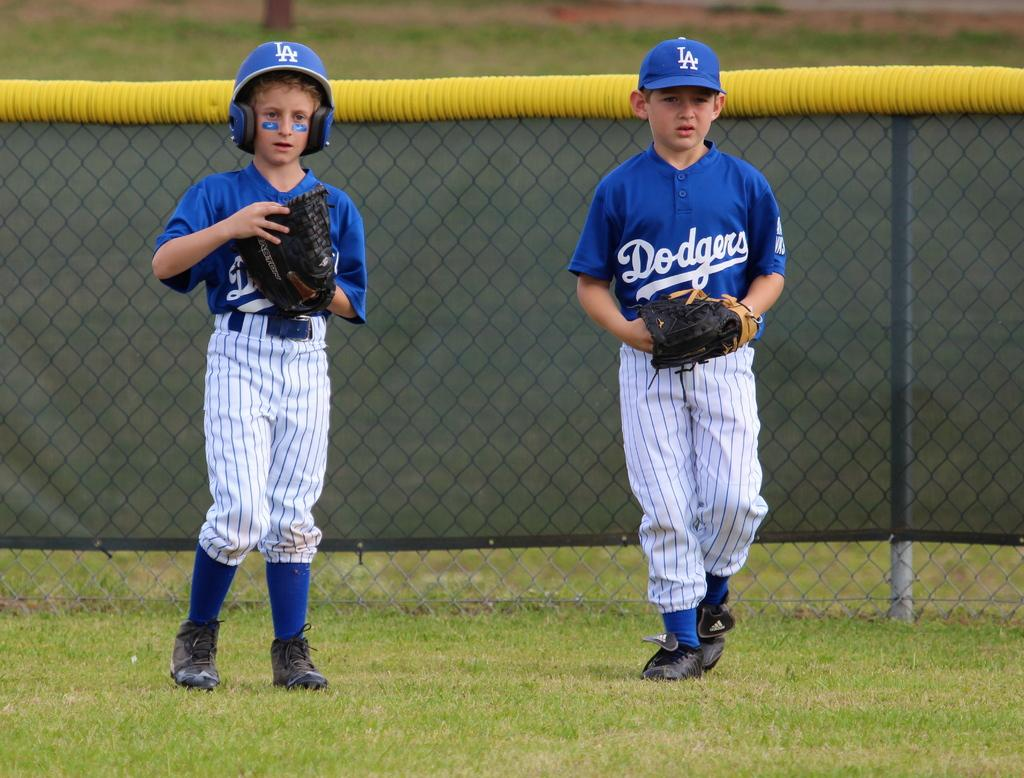<image>
Present a compact description of the photo's key features. Two children play baseball in blue tops with Dodgers written on them. 